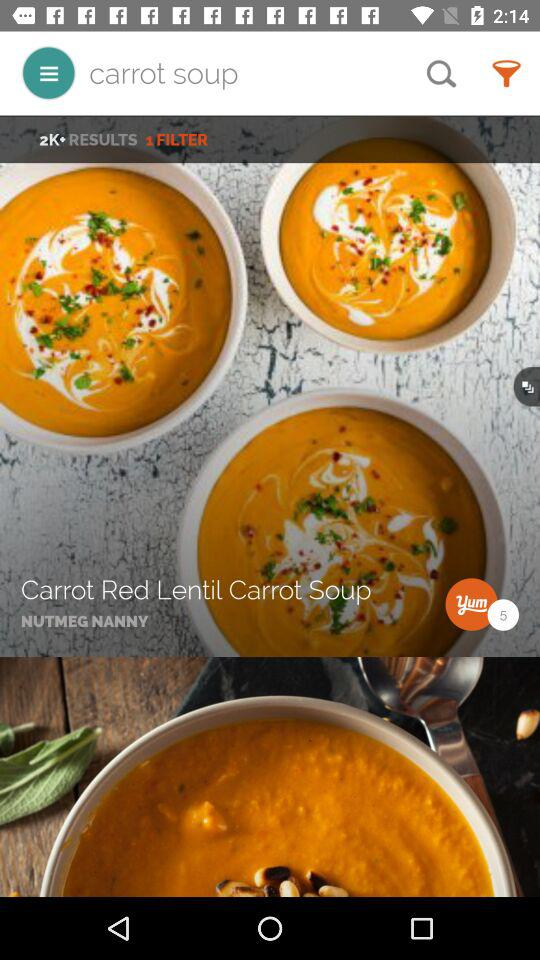How many results have been found? There have been more than 2000 results found. 